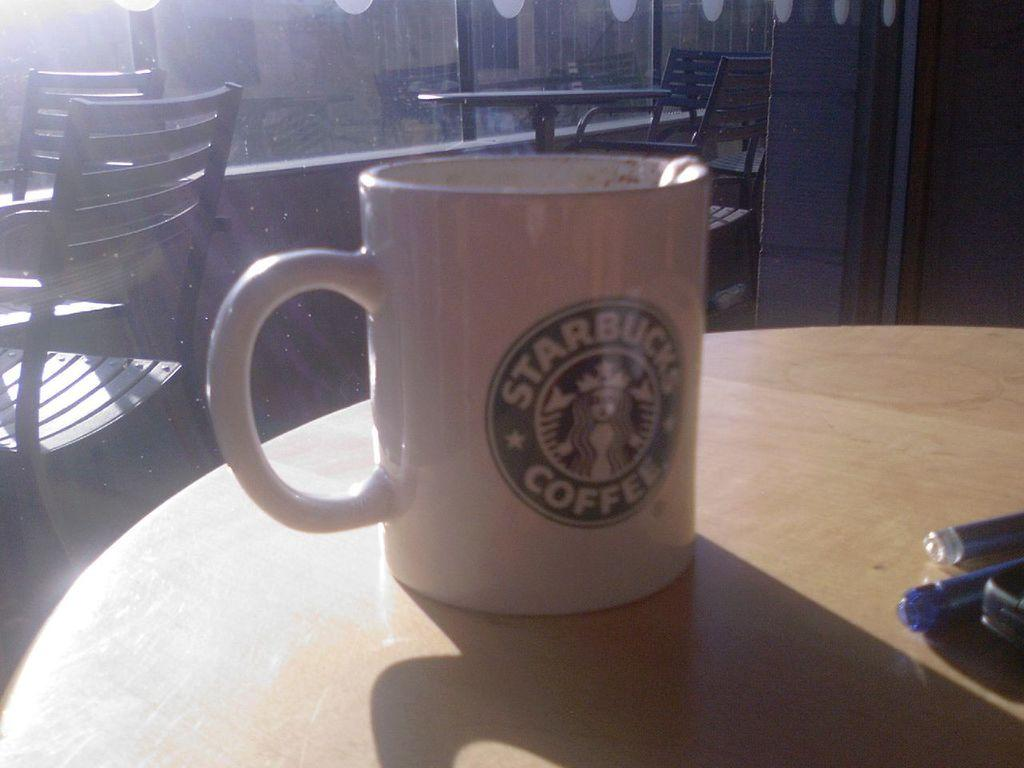Provide a one-sentence caption for the provided image. white starbucks coffee cup on a round wood table with windows in the background. 